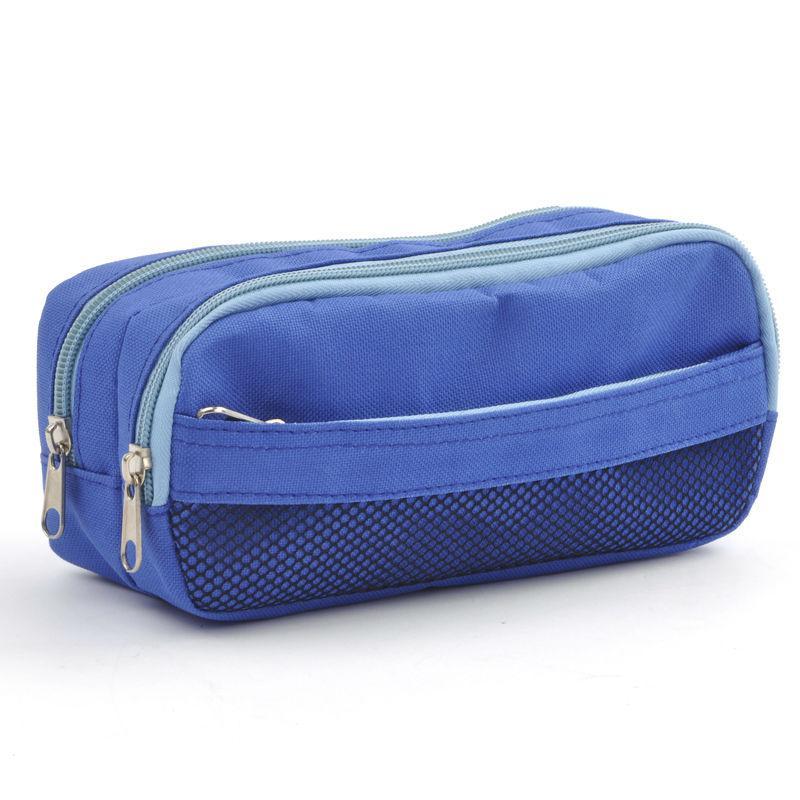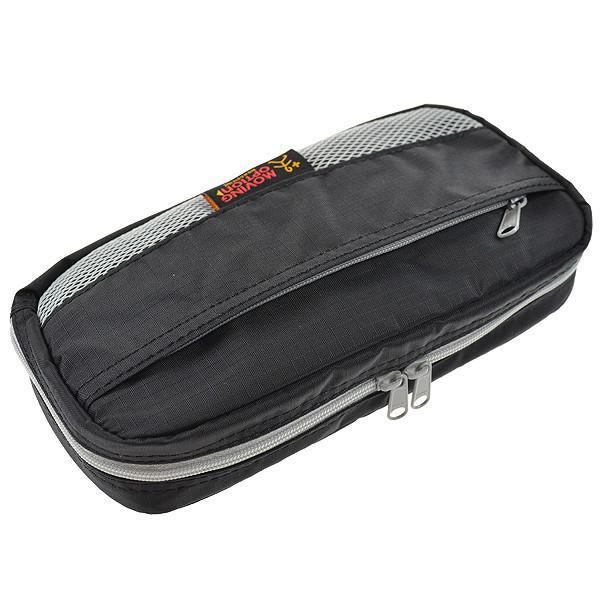The first image is the image on the left, the second image is the image on the right. Evaluate the accuracy of this statement regarding the images: "One bag is unzipped.". Is it true? Answer yes or no. No. The first image is the image on the left, the second image is the image on the right. Given the left and right images, does the statement "A pouch is unzipped  and open in one of the images." hold true? Answer yes or no. No. 